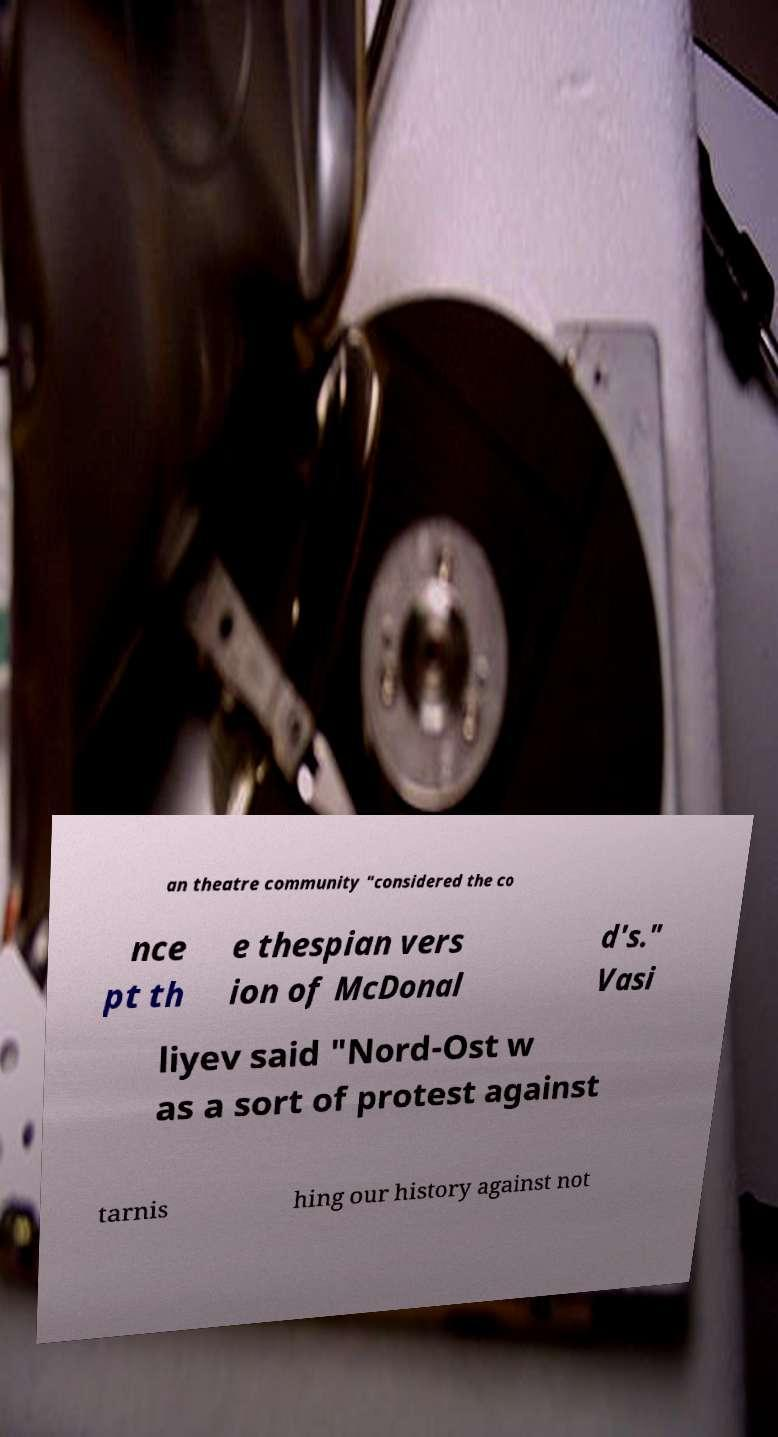Can you read and provide the text displayed in the image?This photo seems to have some interesting text. Can you extract and type it out for me? an theatre community "considered the co nce pt th e thespian vers ion of McDonal d's." Vasi liyev said "Nord-Ost w as a sort of protest against tarnis hing our history against not 